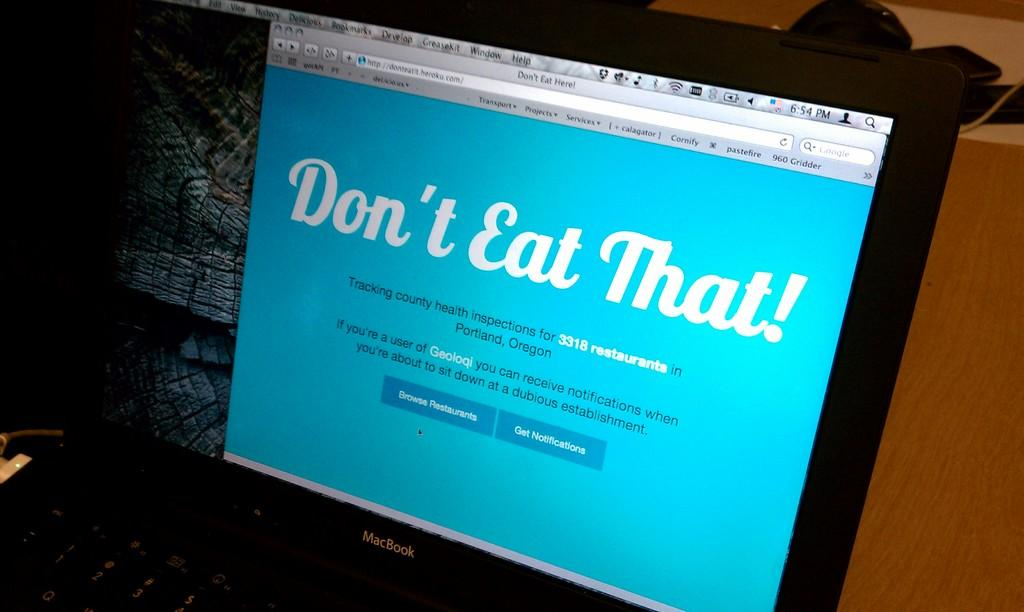<image>
Write a terse but informative summary of the picture. Black Macbook that has as blue screen and words that say Don't eat That. 